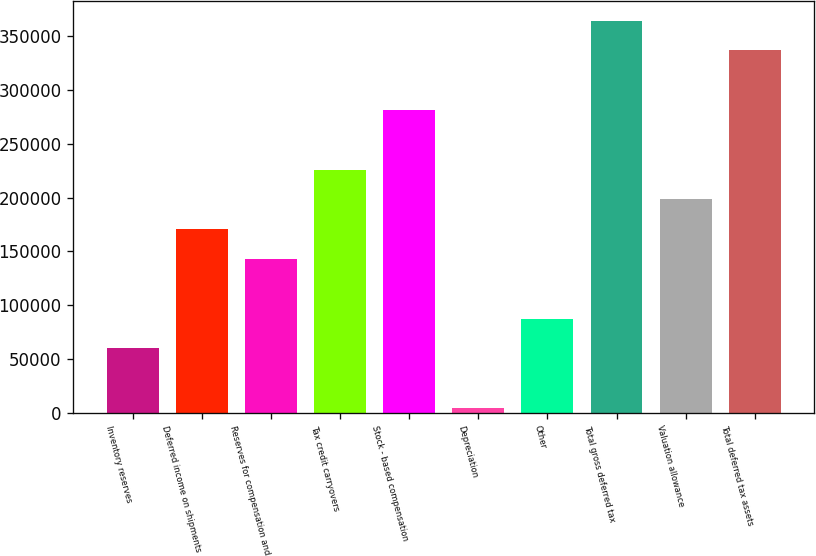<chart> <loc_0><loc_0><loc_500><loc_500><bar_chart><fcel>Inventory reserves<fcel>Deferred income on shipments<fcel>Reserves for compensation and<fcel>Tax credit carryovers<fcel>Stock - based compensation<fcel>Depreciation<fcel>Other<fcel>Total gross deferred tax<fcel>Valuation allowance<fcel>Total deferred tax assets<nl><fcel>59871.8<fcel>170601<fcel>142919<fcel>225966<fcel>281331<fcel>4507<fcel>87554.2<fcel>364378<fcel>198284<fcel>336696<nl></chart> 